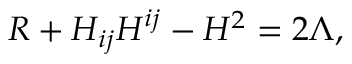Convert formula to latex. <formula><loc_0><loc_0><loc_500><loc_500>R + H _ { i j } H ^ { i j } - H ^ { 2 } = 2 \Lambda ,</formula> 